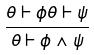Convert formula to latex. <formula><loc_0><loc_0><loc_500><loc_500>\frac { \theta \vdash \phi \theta \vdash \psi } { \theta \vdash \phi \wedge \psi }</formula> 